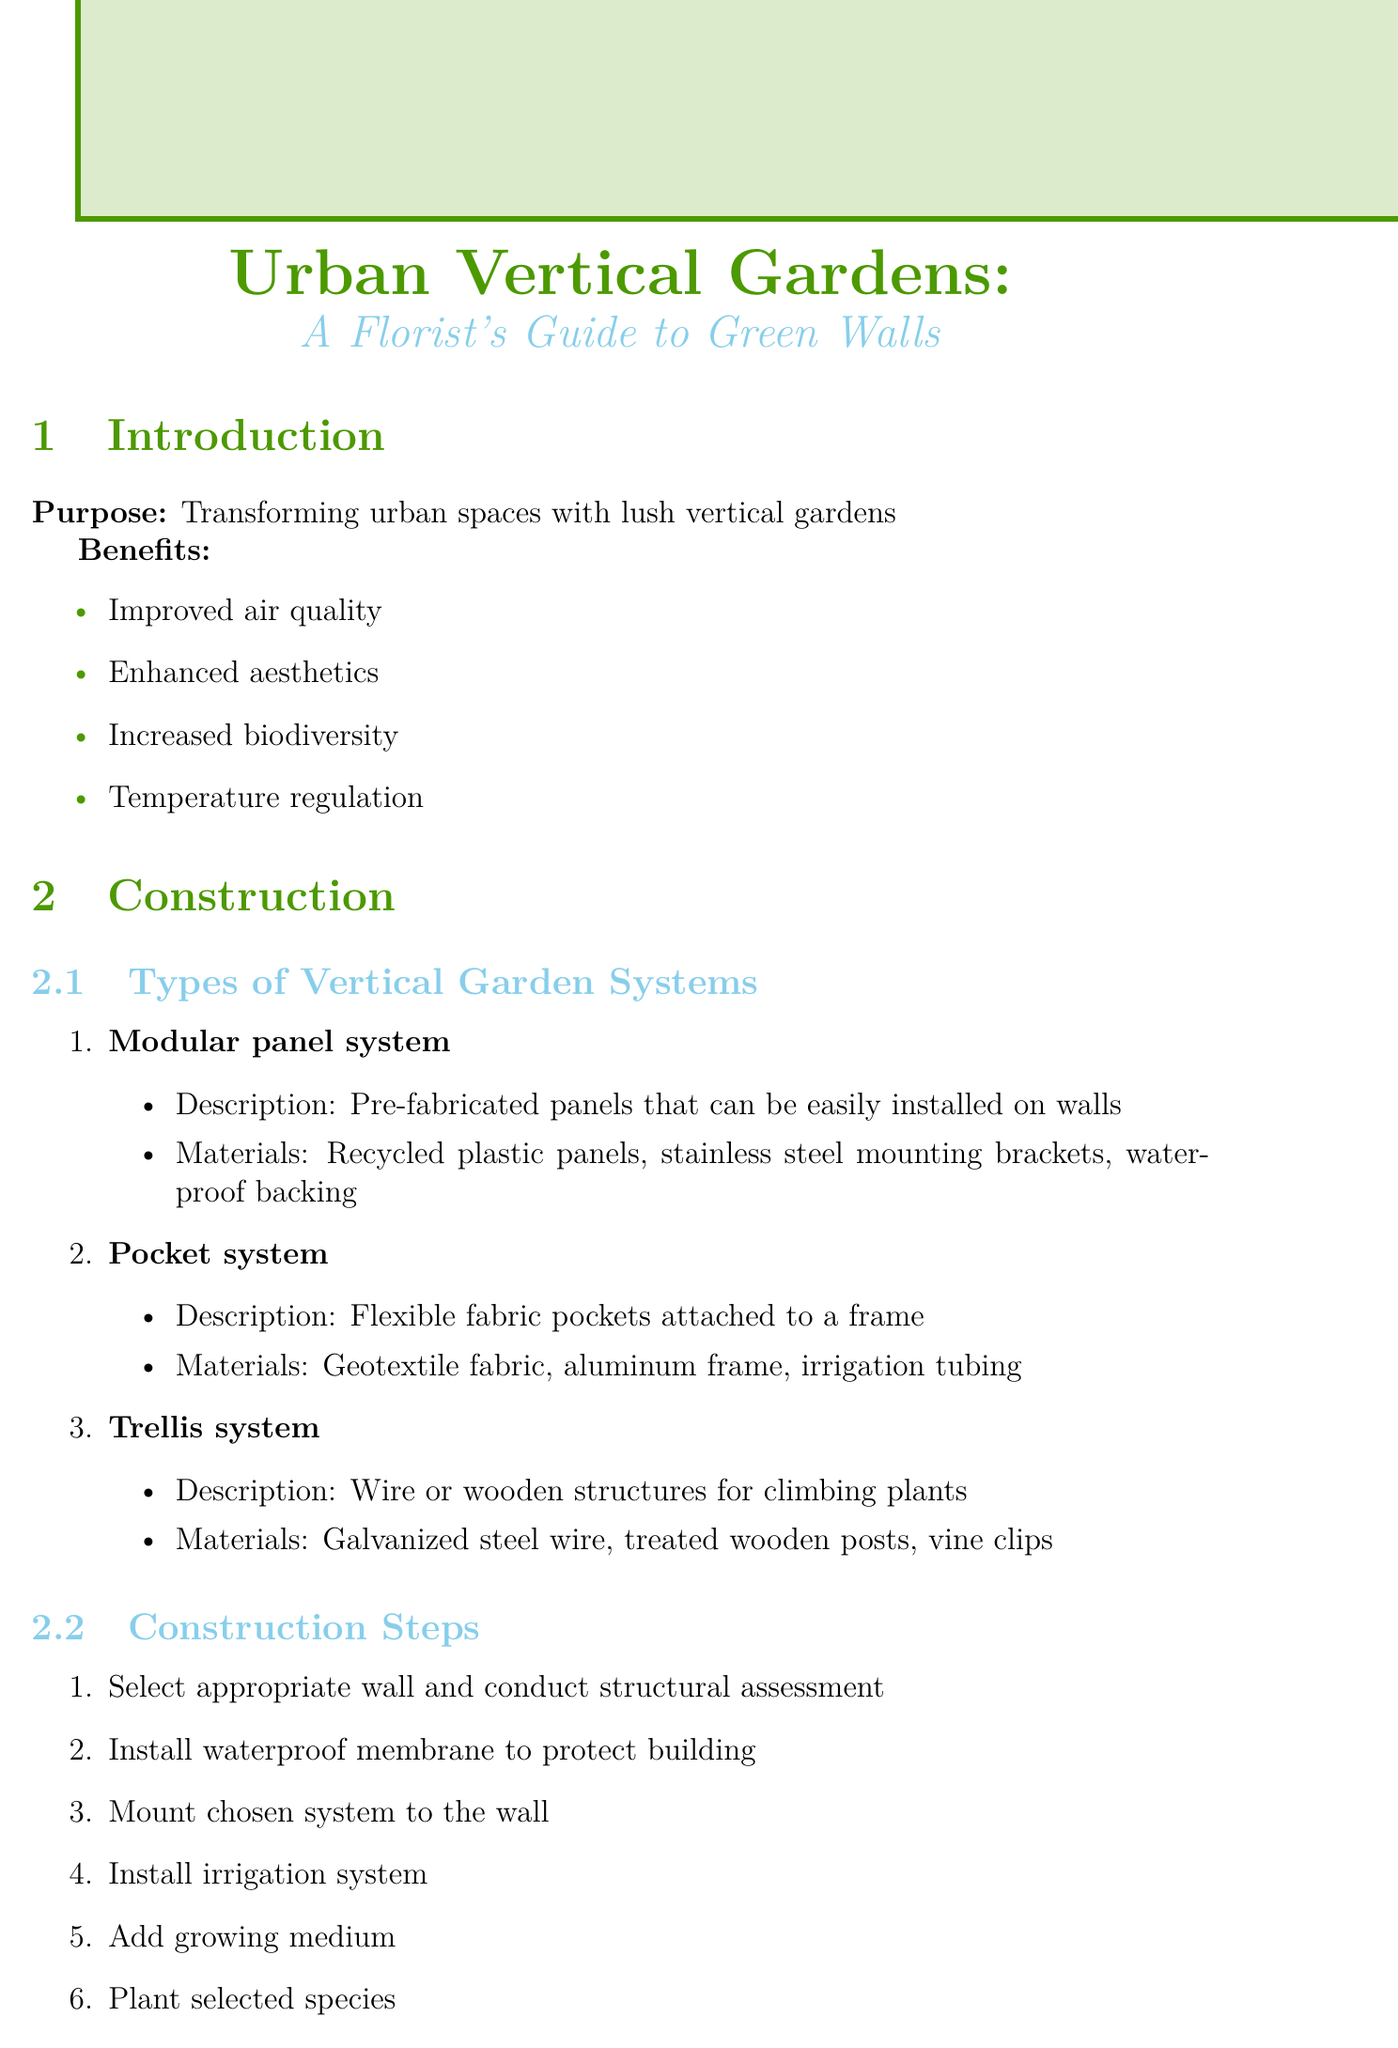What is the purpose of the document? The purpose of the document is to transform urban spaces with lush vertical gardens.
Answer: Transforming urban spaces with lush vertical gardens How many types of vertical garden systems are listed? The number of types of vertical garden systems is provided in the construction section.
Answer: Three What is a benefit of using Sedum? The document lists various benefits under plant selection for each recommended species.
Answer: Drought-tolerant, varied textures What is the recommended frequency for watering? The recommended frequency for watering is specified in the maintenance section.
Answer: Daily to weekly What materials are used in the pocket system? The specific materials for each vertical garden system are mentioned in their descriptions.
Answer: Geotextile fabric, aluminum frame, irrigation tubing What is one of the tasks of community engagement? Ideas for community engagement are listed under their dedicated section.
Answer: Organize community planting days What component is necessary for drip irrigation? The components for each irrigation system are outlined in the document.
Answer: Polyethylene tubing What symptom indicates a possible pest infestation? Symptoms of common issues with solutions are provided in the troubleshooting section.
Answer: Yellowing leaves 